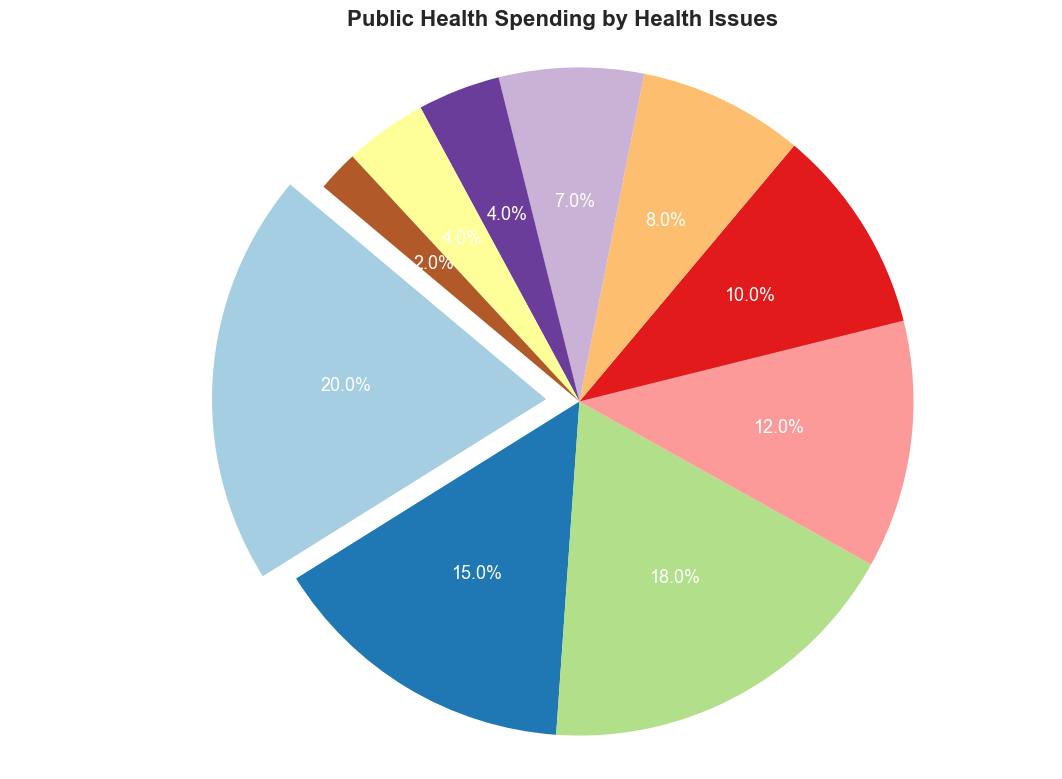Which category has the highest percentage of public health spending? The pie chart labels reveal each category's percentage, showing that Cardiovascular Diseases have the highest at 20%.
Answer: Cardiovascular Diseases Compare the spending on Cancer and Diabetes. Which one is higher, and by how much? From the pie chart, Cancer has 18% and Diabetes has 10%. The difference is 18% - 10% = 8%.
Answer: Cancer by 8% What is the combined percentage of spending on Mental Health and Neurological Disorders? The percentages from the pie chart for Mental Health and Neurological Disorders are 12% and 4%, respectively. Adding them gives 12% + 4% = 16%.
Answer: 16% Which category uses the least percentage of the budget, and what is that percentage? The chart shows that the "Other" category has the smallest segment with 2%.
Answer: Other, 2% Does the spending on Respiratory Diseases outnumber the combined spending on Gastrointestinal Diseases and Other? The pie chart shows Respiratory Diseases at 7%, Gastrointestinal Diseases at 4%, and Other at 2%. Adding the latter two gives 4% + 2% = 6%, which is less than 7%.
Answer: Yes What color represents Infectious Diseases in the pie chart? Observing the pie chart's labeled segments, Infectious Diseases is assigned a specific visual color distinct from the others.
Answer: [Assuming hypothetical context without visual]: What is the approximate visual size difference between Cardiovascular Diseases and Neurological Disorders? Cardiovascular Diseases take up 20%, and Neurological Disorders take up 4% of the pie chart, so Cardiovascular Diseases are approximately five times larger visually on the chart.
Answer: Five times larger Which categories have less than 10% of the budget allocation? From the pie chart, Maternal and Child Health (8%), Respiratory Diseases (7%), Neurological Disorders (4%), Gastrointestinal Diseases (4%), and Other (2%) fall below 10%.
Answer: Maternal and Child Health, Respiratory Diseases, Neurological Disorders, Gastrointestinal Diseases, Other How does the spending on Cardiovascular Diseases compare to the sum of Diabetes and Maternal and Child Health? Cardiovascular Diseases have 20%. The sum of Diabetes (10%) and Maternal and Child Health (8%) is 10% + 8% = 18%. Hence, Cardiovascular Diseases have 2% more.
Answer: Cardiovascular Diseases by 2% If the total budget were $1,000,000, how much would be allocated to Cancer? Given that Cancer takes up 18% of the budget, translating this percentage to a $1,000,000 budget results in 0.18 x $1,000,000 = $180,000.
Answer: $180,000 